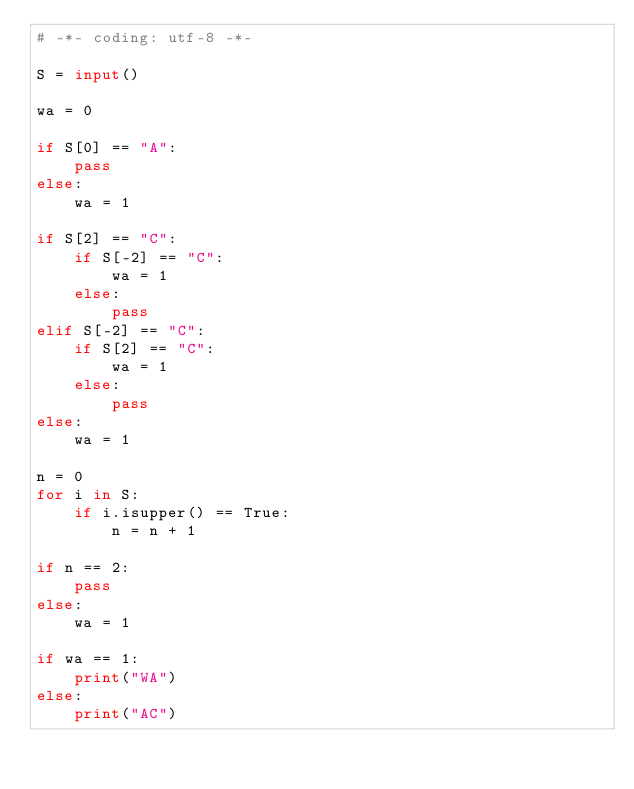<code> <loc_0><loc_0><loc_500><loc_500><_Python_># -*- coding: utf-8 -*-

S = input()

wa = 0

if S[0] == "A":
    pass
else:
    wa = 1

if S[2] == "C":
    if S[-2] == "C":
        wa = 1
    else:
        pass
elif S[-2] == "C":
    if S[2] == "C":
        wa = 1
    else:
        pass
else:
    wa = 1

n = 0
for i in S:
    if i.isupper() == True:
        n = n + 1

if n == 2:
    pass
else:
    wa = 1        

if wa == 1:
    print("WA")
else:
    print("AC")</code> 